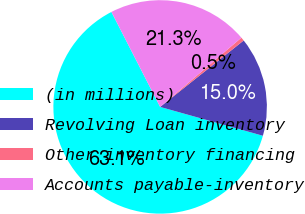<chart> <loc_0><loc_0><loc_500><loc_500><pie_chart><fcel>(in millions)<fcel>Revolving Loan inventory<fcel>Other inventory financing<fcel>Accounts payable-inventory<nl><fcel>63.11%<fcel>15.05%<fcel>0.54%<fcel>21.31%<nl></chart> 